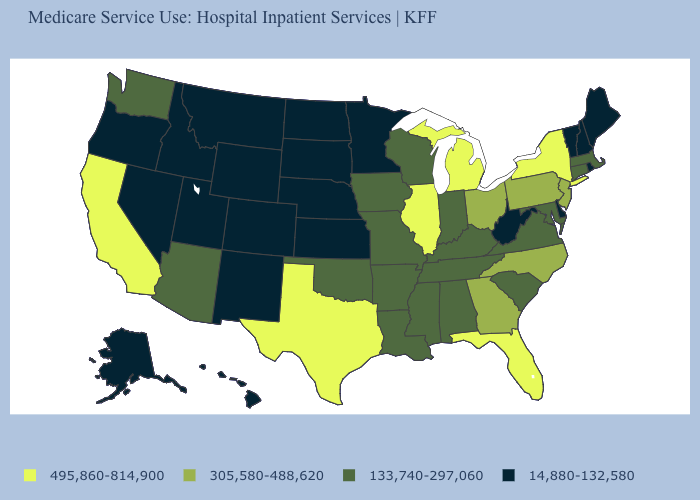Name the states that have a value in the range 495,860-814,900?
Give a very brief answer. California, Florida, Illinois, Michigan, New York, Texas. Which states hav the highest value in the West?
Concise answer only. California. What is the value of North Carolina?
Keep it brief. 305,580-488,620. Name the states that have a value in the range 133,740-297,060?
Quick response, please. Alabama, Arizona, Arkansas, Connecticut, Indiana, Iowa, Kentucky, Louisiana, Maryland, Massachusetts, Mississippi, Missouri, Oklahoma, South Carolina, Tennessee, Virginia, Washington, Wisconsin. Which states hav the highest value in the Northeast?
Answer briefly. New York. Among the states that border Wisconsin , does Minnesota have the lowest value?
Be succinct. Yes. What is the value of Virginia?
Be succinct. 133,740-297,060. Does Washington have the lowest value in the West?
Give a very brief answer. No. What is the value of South Carolina?
Be succinct. 133,740-297,060. Does Delaware have the lowest value in the USA?
Answer briefly. Yes. What is the value of New Jersey?
Concise answer only. 305,580-488,620. Which states have the highest value in the USA?
Be succinct. California, Florida, Illinois, Michigan, New York, Texas. Name the states that have a value in the range 305,580-488,620?
Quick response, please. Georgia, New Jersey, North Carolina, Ohio, Pennsylvania. Is the legend a continuous bar?
Be succinct. No. What is the lowest value in states that border Iowa?
Short answer required. 14,880-132,580. 